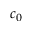<formula> <loc_0><loc_0><loc_500><loc_500>c _ { 0 }</formula> 